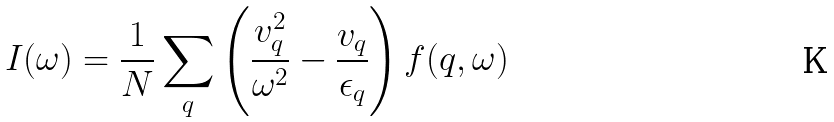Convert formula to latex. <formula><loc_0><loc_0><loc_500><loc_500>I ( \omega ) = \frac { 1 } { N } \sum _ { q } \left ( \frac { v ^ { 2 } _ { q } } { \omega ^ { 2 } } - \frac { v _ { q } } { \epsilon _ { q } } \right ) f ( { q } , \omega )</formula> 